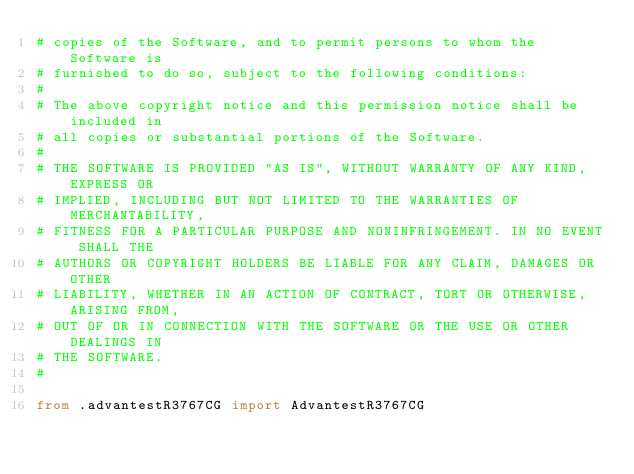Convert code to text. <code><loc_0><loc_0><loc_500><loc_500><_Python_># copies of the Software, and to permit persons to whom the Software is
# furnished to do so, subject to the following conditions:
#
# The above copyright notice and this permission notice shall be included in
# all copies or substantial portions of the Software.
#
# THE SOFTWARE IS PROVIDED "AS IS", WITHOUT WARRANTY OF ANY KIND, EXPRESS OR
# IMPLIED, INCLUDING BUT NOT LIMITED TO THE WARRANTIES OF MERCHANTABILITY,
# FITNESS FOR A PARTICULAR PURPOSE AND NONINFRINGEMENT. IN NO EVENT SHALL THE
# AUTHORS OR COPYRIGHT HOLDERS BE LIABLE FOR ANY CLAIM, DAMAGES OR OTHER
# LIABILITY, WHETHER IN AN ACTION OF CONTRACT, TORT OR OTHERWISE, ARISING FROM,
# OUT OF OR IN CONNECTION WITH THE SOFTWARE OR THE USE OR OTHER DEALINGS IN
# THE SOFTWARE.
#

from .advantestR3767CG import AdvantestR3767CG
</code> 